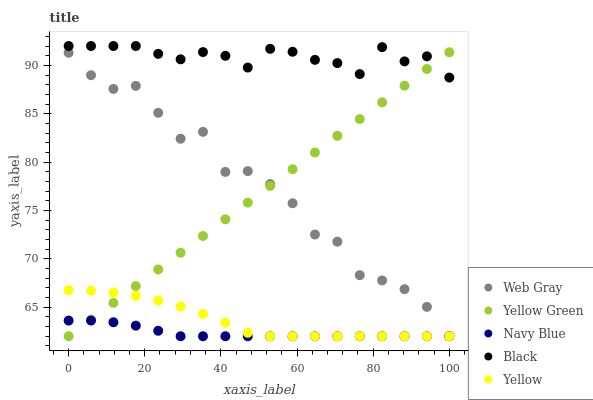Does Navy Blue have the minimum area under the curve?
Answer yes or no. Yes. Does Black have the maximum area under the curve?
Answer yes or no. Yes. Does Web Gray have the minimum area under the curve?
Answer yes or no. No. Does Web Gray have the maximum area under the curve?
Answer yes or no. No. Is Yellow Green the smoothest?
Answer yes or no. Yes. Is Web Gray the roughest?
Answer yes or no. Yes. Is Black the smoothest?
Answer yes or no. No. Is Black the roughest?
Answer yes or no. No. Does Navy Blue have the lowest value?
Answer yes or no. Yes. Does Black have the lowest value?
Answer yes or no. No. Does Black have the highest value?
Answer yes or no. Yes. Does Web Gray have the highest value?
Answer yes or no. No. Is Web Gray less than Black?
Answer yes or no. Yes. Is Black greater than Web Gray?
Answer yes or no. Yes. Does Yellow intersect Web Gray?
Answer yes or no. Yes. Is Yellow less than Web Gray?
Answer yes or no. No. Is Yellow greater than Web Gray?
Answer yes or no. No. Does Web Gray intersect Black?
Answer yes or no. No. 